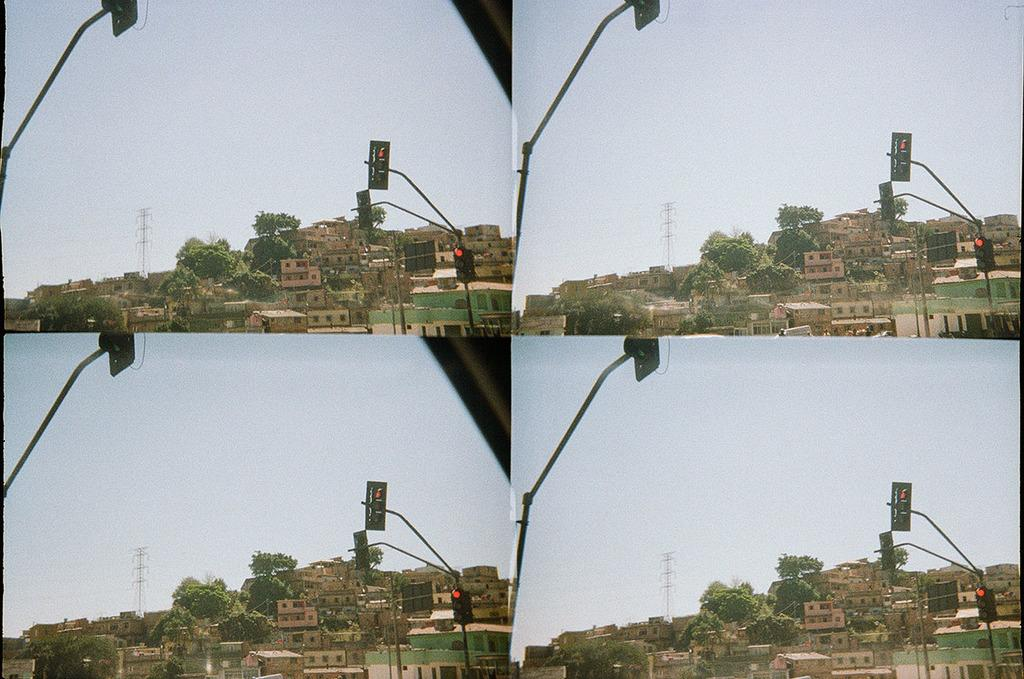How many pictures are present in the image? There are four pictures in the image. What is a common element in each of the pictures? Each picture contains a traffic signal pole, a board, a building, trees, a tower, and the sky is visible in the background. What type of structure can be seen in each picture? Each picture contains a building. What natural elements are present in each picture? Each picture contains trees. How many kittens are playing with a quilt in the image? There are no kittens or quilts present in the image. Is there a crowd visible in any of the pictures? No, there is no crowd visible in any of the pictures; the focus is on individual elements such as traffic signal poles, boards, buildings, trees, and towers. 